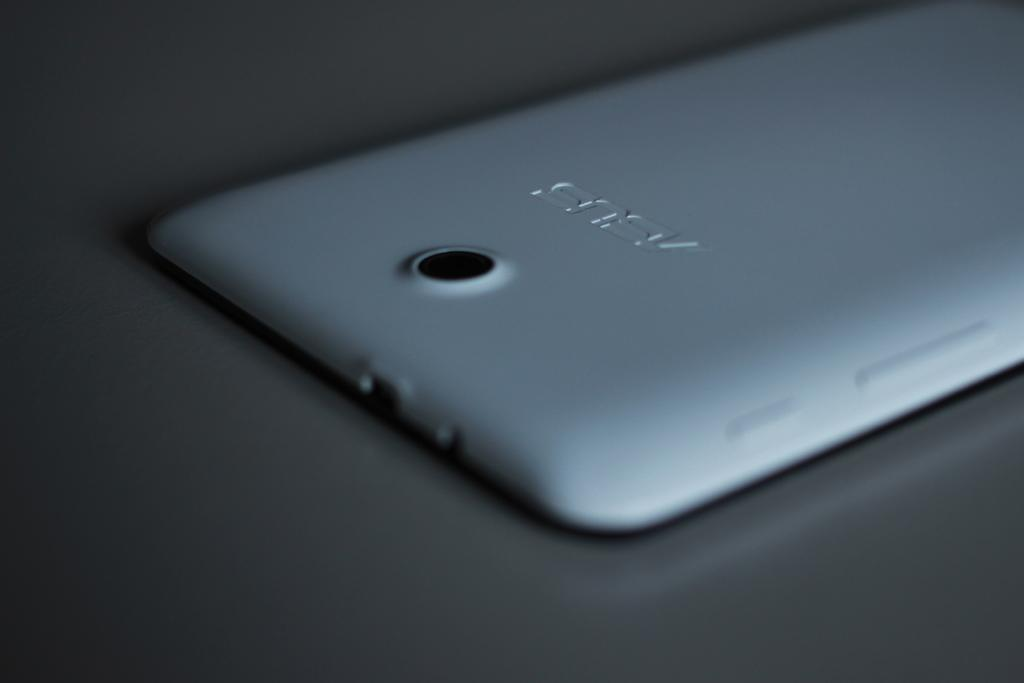<image>
Summarize the visual content of the image. A white Asus cell phone lays face down on a gray surface. 